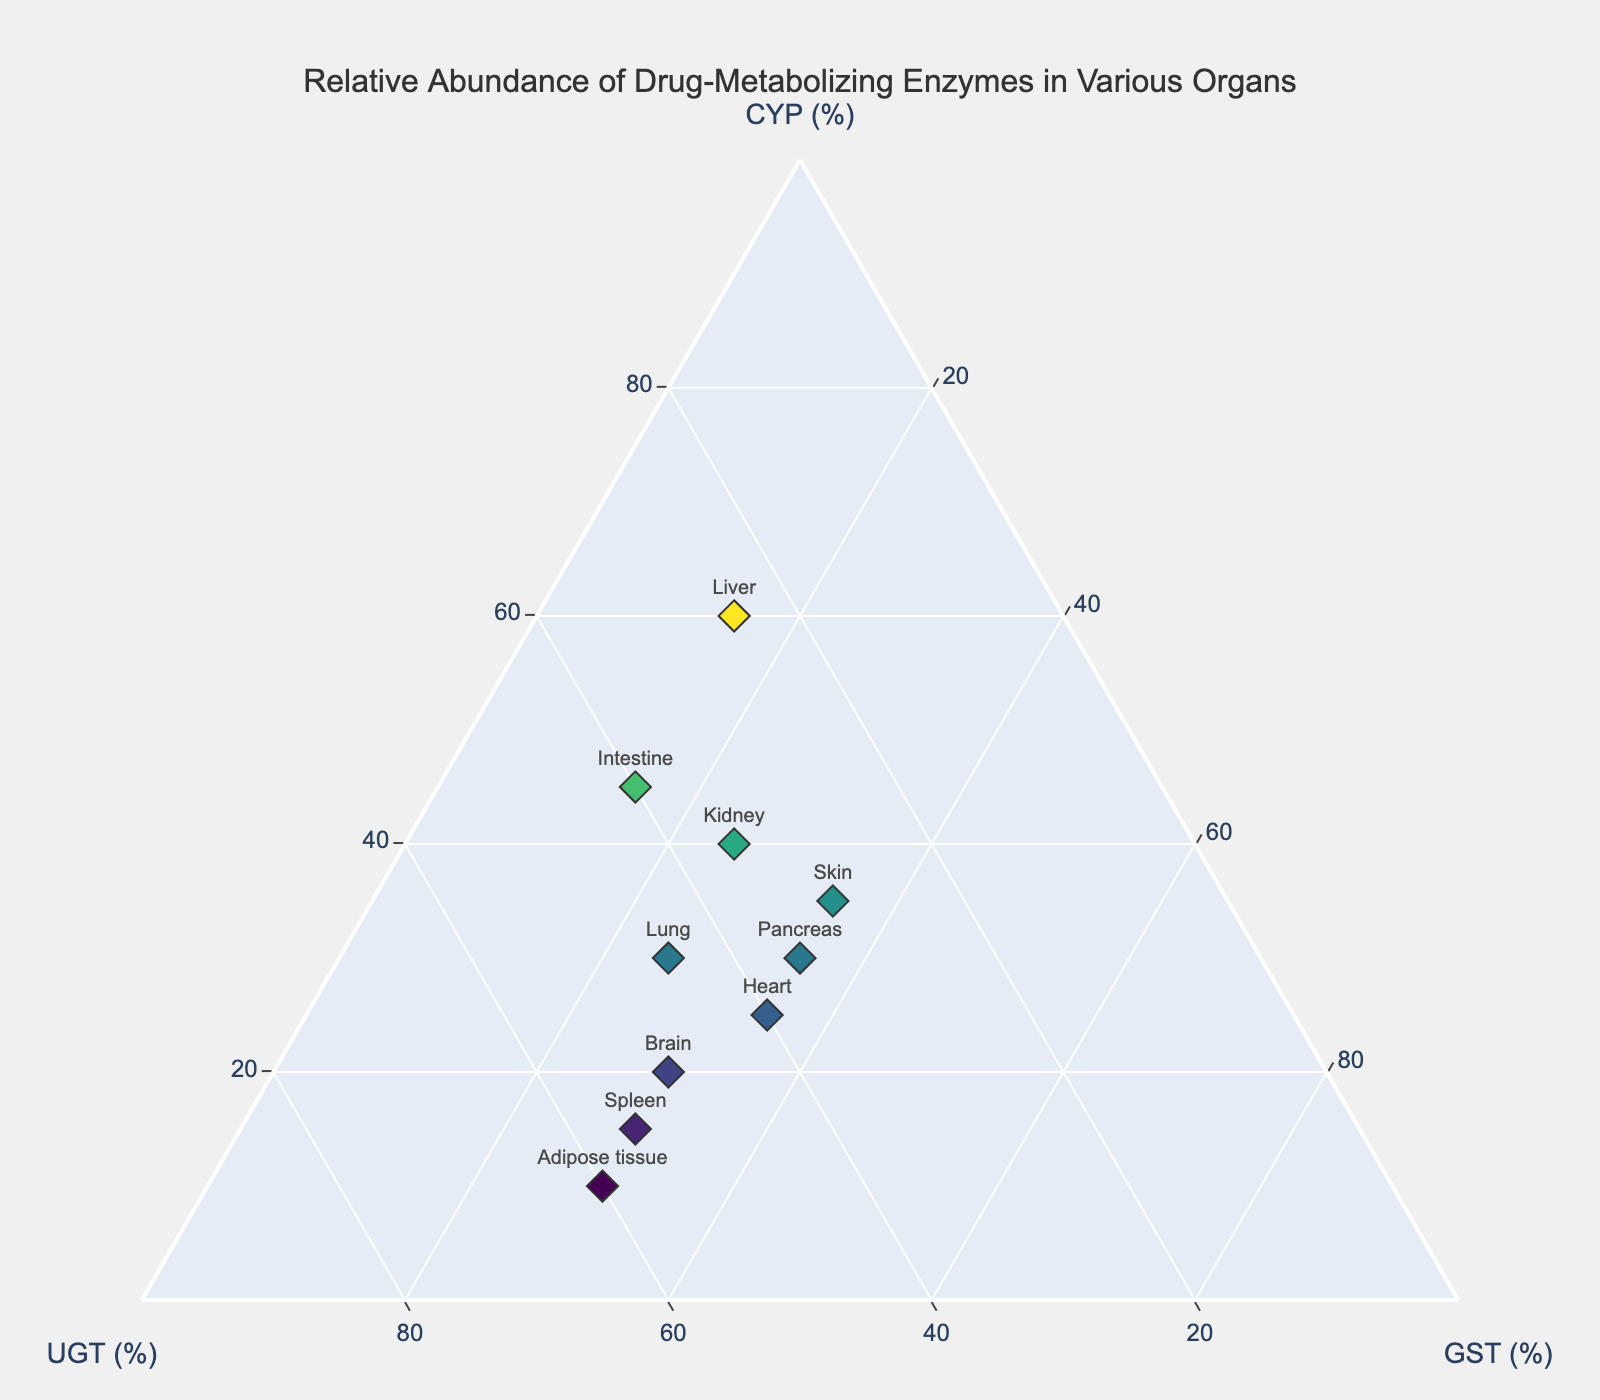What's the title of the figure? The title is usually located at the top of the figure. Upon examining the figure, the title reads "Relative Abundance of Drug-Metabolizing Enzymes in Various Organs."
Answer: Relative Abundance of Drug-Metabolizing Enzymes in Various Organs How many organs are represented in the plot? To determine the number of organs, count the number of data points or labels in the figure. By examining the plotted points, we can see there are 10 distinct organs.
Answer: 10 Which organ has the highest relative abundance of UGT? To find the organ with the highest UGT%, look at the axis labeled UGT and identify the organ with the highest value on this axis. From the plot, Adipose tissue has the highest UGT value at 60%.
Answer: Adipose tissue What is the relative abundance sum of CYP and GST in the liver? The sum can be found by adding the relative abundance values of CYP and GST for the liver. From the plot, liver has 60% CYP and 15% GST. Summing these values: 60 + 15.
Answer: 75% Which organ is closest to the equal distribution of CYP, UGT, and GST? For equal distribution, the values of CYP, UGT, and GST should be close to each other. By checking the plot, the Skin has values of 35% for CYP, 30% for UGT, and 35% for GST, which are the closest to being equal.
Answer: Skin Compare the relative abundance of GST in the brain and kidney. Which is higher? Look at the GST axis values for both brain and kidney. The brain has 30% GST and the kidney has 25% GST. Therefore, the brain has a higher GST abundance.
Answer: Brain Identify the organ with the least relative abundance of CYP. Examine the value on the CYP axis. The Spleen has the least relative abundance of CYP at 15%.
Answer: Spleen What is the average UGT relative abundance across all organs? Add up all the UGT values from the organs and divide by the number of organs. (25 + 35 + 40 + 45 + 50 + 30 + 40 + 35 + 55 + 60) / 10 = 41.5.
Answer: 41.5% Which organ's relative abundance of CYP and UGT combined is closest to 70%? Calculate the sum of CYP and UGT for each organ and compare which is closest to 70%. For the Liver, 60 + 25 = 85; Kidney, 40 + 35 = 75; Intestine, 45 + 40 = 85; Lung, 30 + 45 = 75; Brain, 20 + 50 = 70; Skin, 35 + 30 = 65; Heart, 25 + 40 = 65; Pancreas, 30 + 35 = 65; Spleen, 15 + 55 = 70; Adipose tissue, 10 + 60 = 70. Therefore, Brain, Spleen, and Adipose tissue have a combined value closest to 70%.
Answer: Brain, Spleen, Adipose tissue 